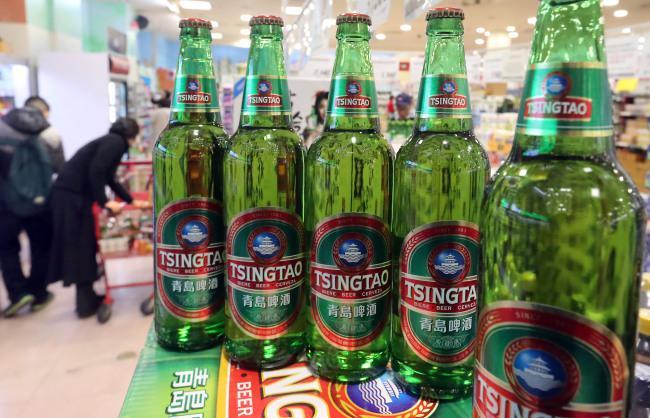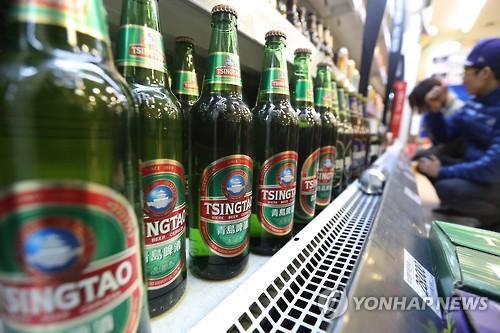The first image is the image on the left, the second image is the image on the right. Assess this claim about the two images: "There are exactly five bottles of beer in the left image.". Correct or not? Answer yes or no. Yes. The first image is the image on the left, the second image is the image on the right. Evaluate the accuracy of this statement regarding the images: "In at least one image there are five unopened green beer bottles.". Is it true? Answer yes or no. Yes. 